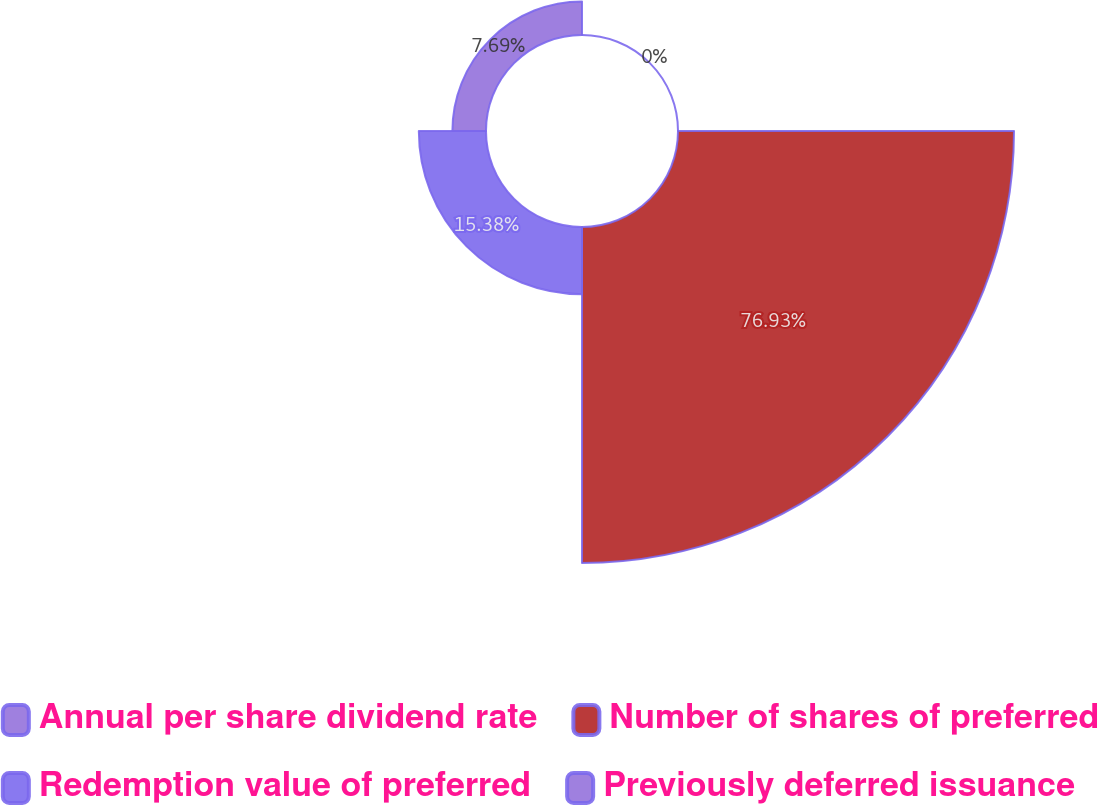<chart> <loc_0><loc_0><loc_500><loc_500><pie_chart><fcel>Annual per share dividend rate<fcel>Number of shares of preferred<fcel>Redemption value of preferred<fcel>Previously deferred issuance<nl><fcel>0.0%<fcel>76.92%<fcel>15.38%<fcel>7.69%<nl></chart> 